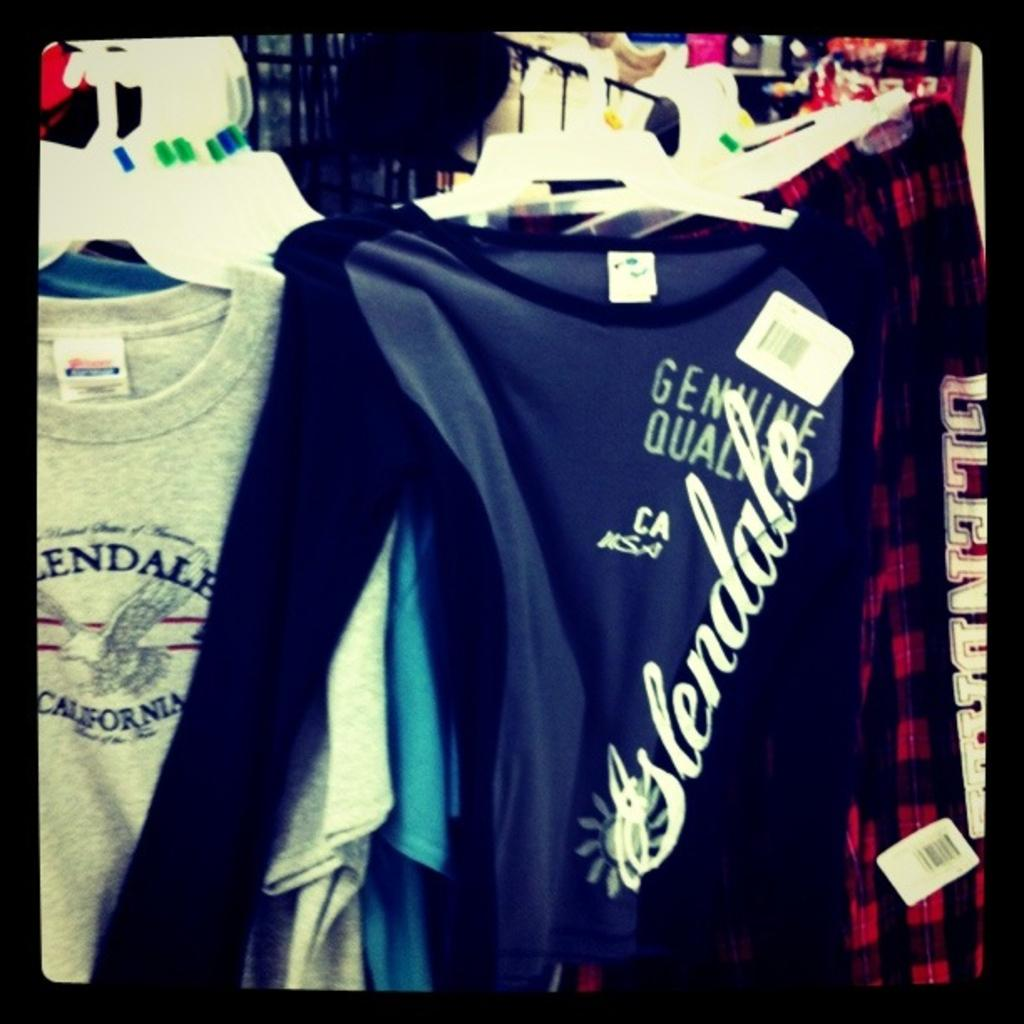<image>
Relay a brief, clear account of the picture shown. A blue shirt saying glendale on it is next to a grey shirt also saying glendale on it 